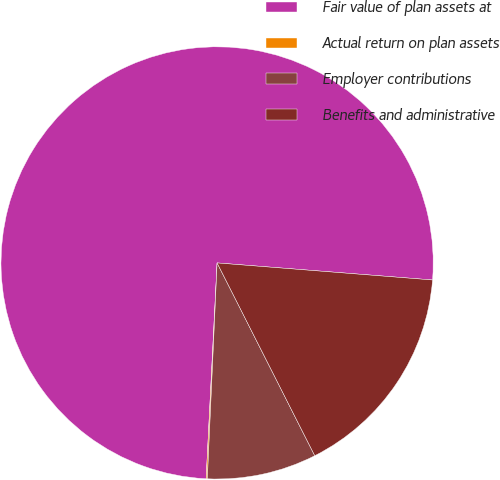<chart> <loc_0><loc_0><loc_500><loc_500><pie_chart><fcel>Fair value of plan assets at<fcel>Actual return on plan assets<fcel>Employer contributions<fcel>Benefits and administrative<nl><fcel>75.45%<fcel>0.09%<fcel>8.18%<fcel>16.28%<nl></chart> 